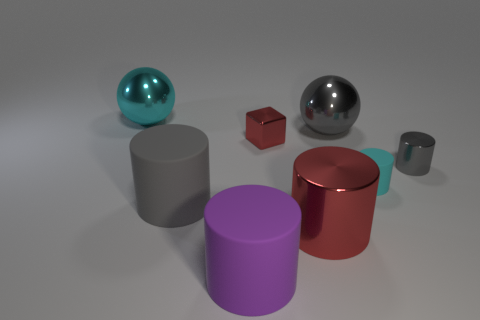There is a cube that is the same color as the big metallic cylinder; what is its size?
Offer a terse response. Small. What is the size of the sphere that is left of the gray cylinder left of the large sphere in front of the large cyan shiny thing?
Provide a short and direct response. Large. How many red cubes have the same material as the large cyan sphere?
Make the answer very short. 1. What number of blocks have the same size as the cyan rubber object?
Provide a short and direct response. 1. What material is the gray cylinder on the right side of the big metallic ball on the right side of the cyan thing behind the tiny red shiny cube?
Provide a succinct answer. Metal. How many things are small rubber cylinders or small purple shiny cubes?
Provide a short and direct response. 1. There is a big red thing; what shape is it?
Your answer should be compact. Cylinder. What is the shape of the cyan thing that is left of the sphere to the right of the red cylinder?
Give a very brief answer. Sphere. Does the sphere right of the small block have the same material as the big purple object?
Make the answer very short. No. How many cyan objects are small blocks or large shiny balls?
Ensure brevity in your answer.  1. 